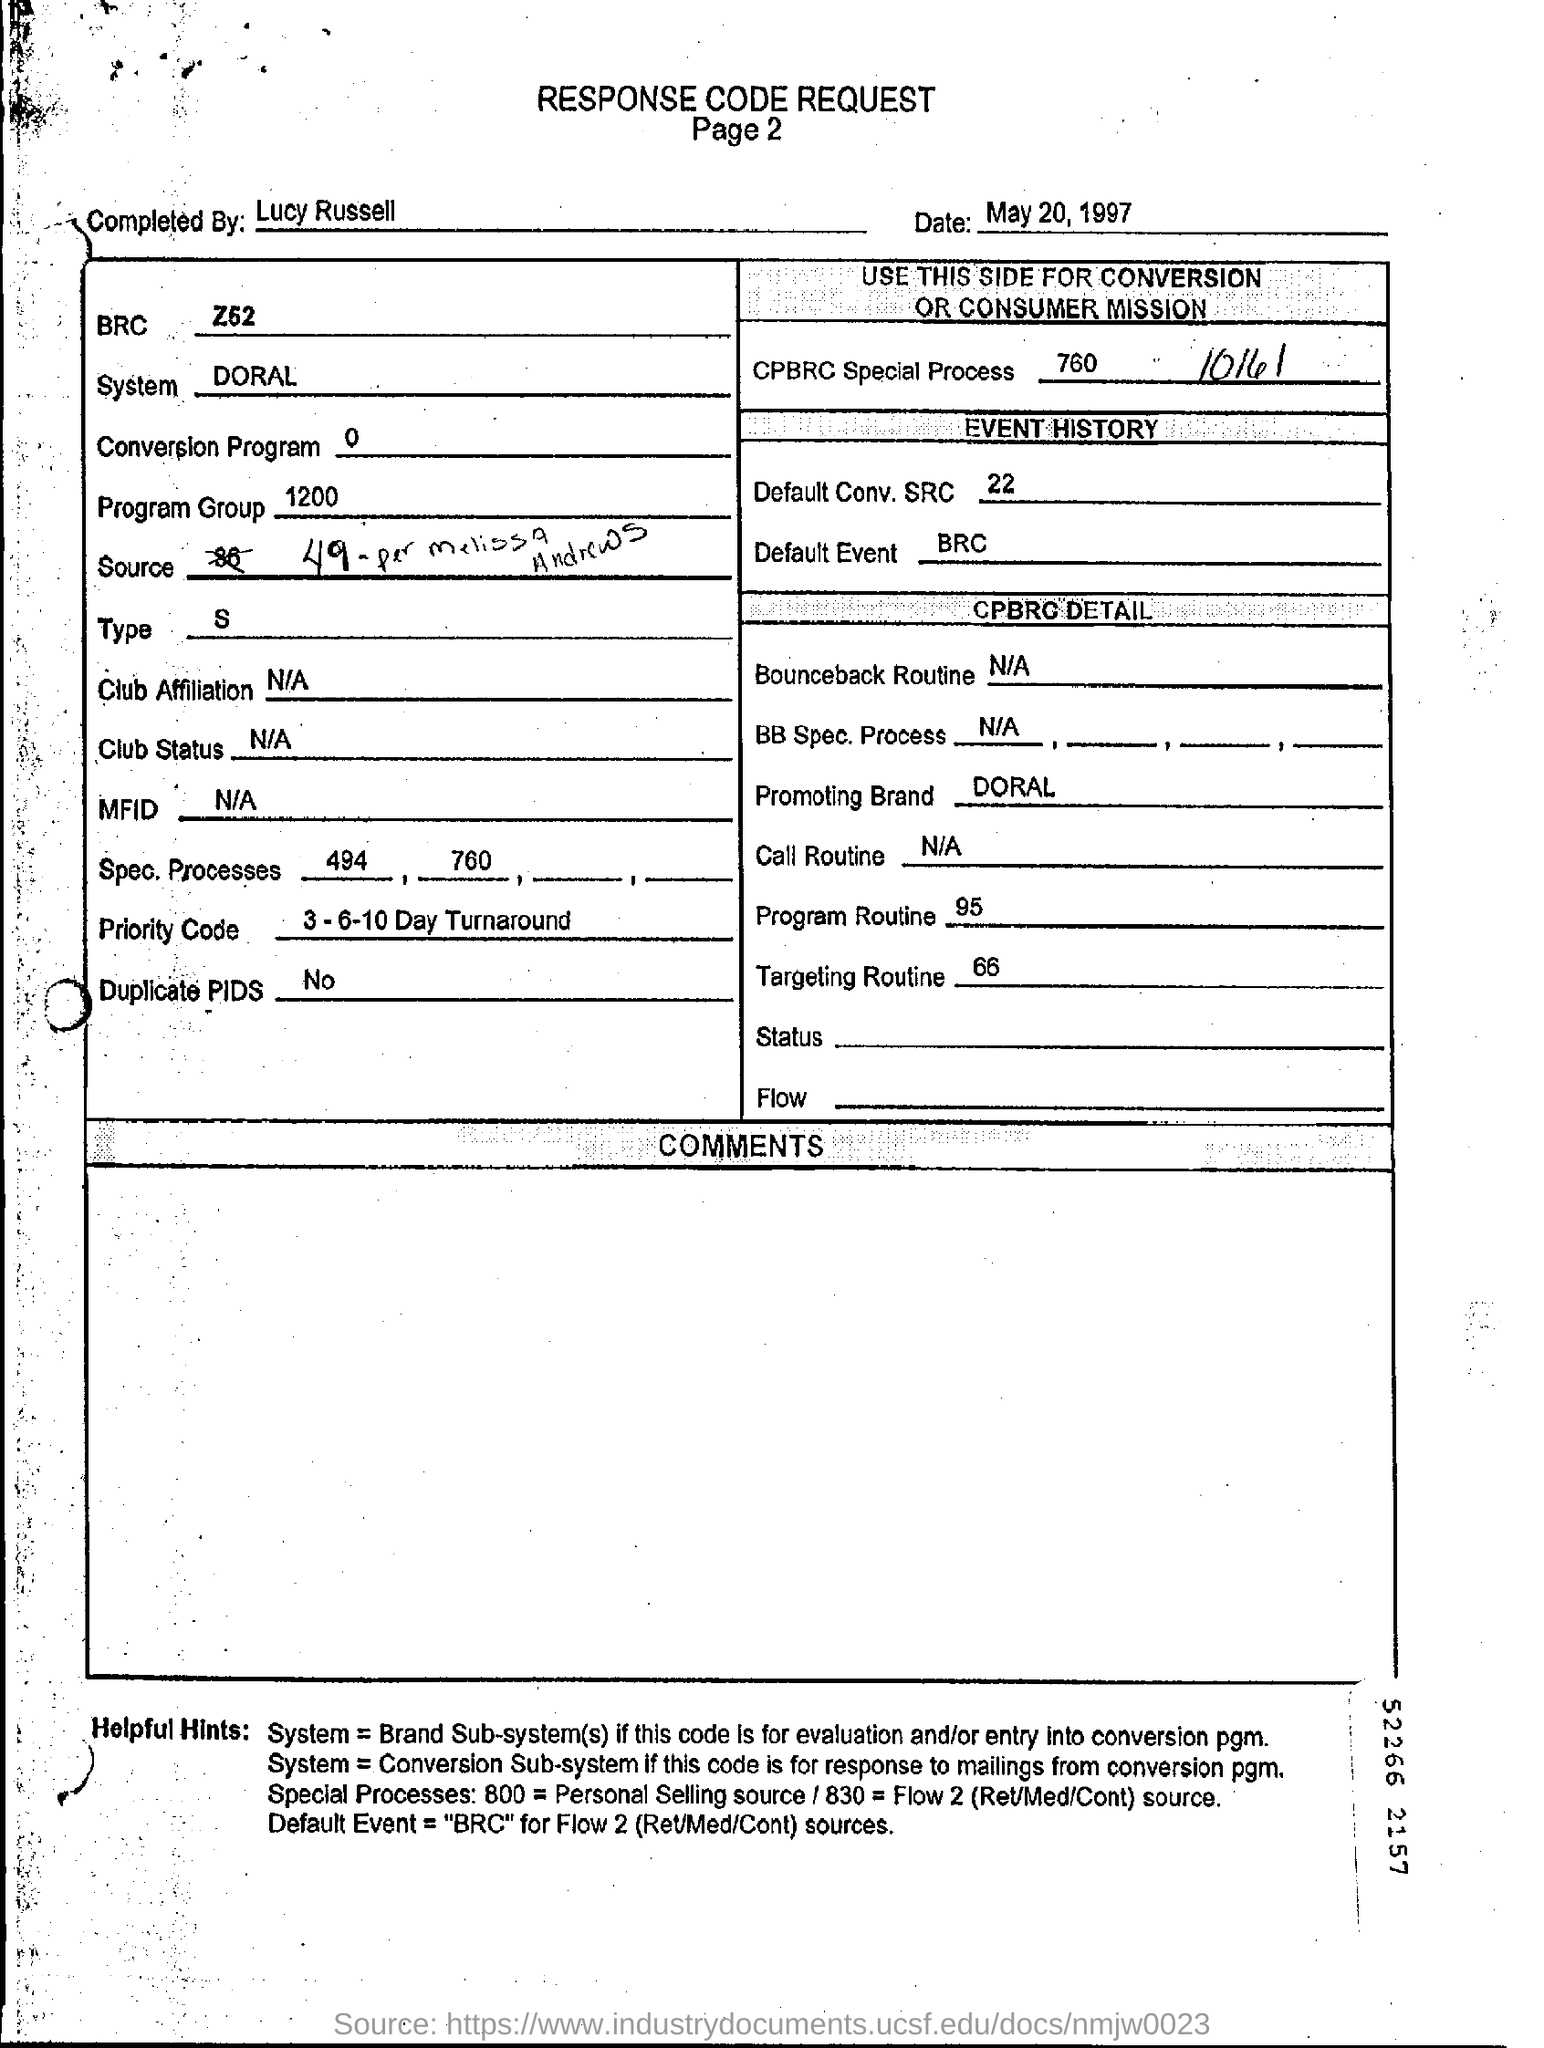Who completed the response code request ?
Your response must be concise. Lucy Russell. What is the program group?
Provide a succinct answer. 1200. Is there any Duplicate PIDS ?
Ensure brevity in your answer.  No. 